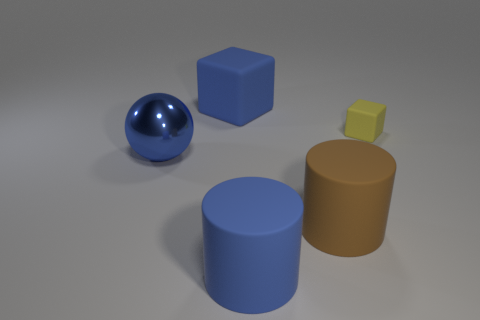Subtract all yellow cubes. How many cubes are left? 1 Add 2 big metallic things. How many objects exist? 7 Subtract 1 cylinders. How many cylinders are left? 1 Add 5 big rubber cylinders. How many big rubber cylinders exist? 7 Subtract 0 purple blocks. How many objects are left? 5 Subtract all spheres. How many objects are left? 4 Subtract all red cubes. Subtract all blue cylinders. How many cubes are left? 2 Subtract all purple blocks. How many purple cylinders are left? 0 Subtract all gray blocks. Subtract all blue cylinders. How many objects are left? 4 Add 4 big blue objects. How many big blue objects are left? 7 